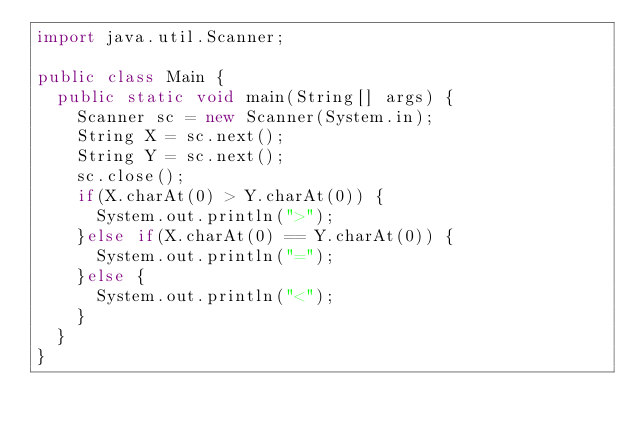<code> <loc_0><loc_0><loc_500><loc_500><_Java_>import java.util.Scanner;

public class Main {
	public static void main(String[] args) {
		Scanner sc = new Scanner(System.in);
		String X = sc.next();
		String Y = sc.next();
		sc.close();
		if(X.charAt(0) > Y.charAt(0)) {
			System.out.println(">");
		}else if(X.charAt(0) == Y.charAt(0)) {
			System.out.println("=");
		}else {
			System.out.println("<");
		}
	}
}</code> 